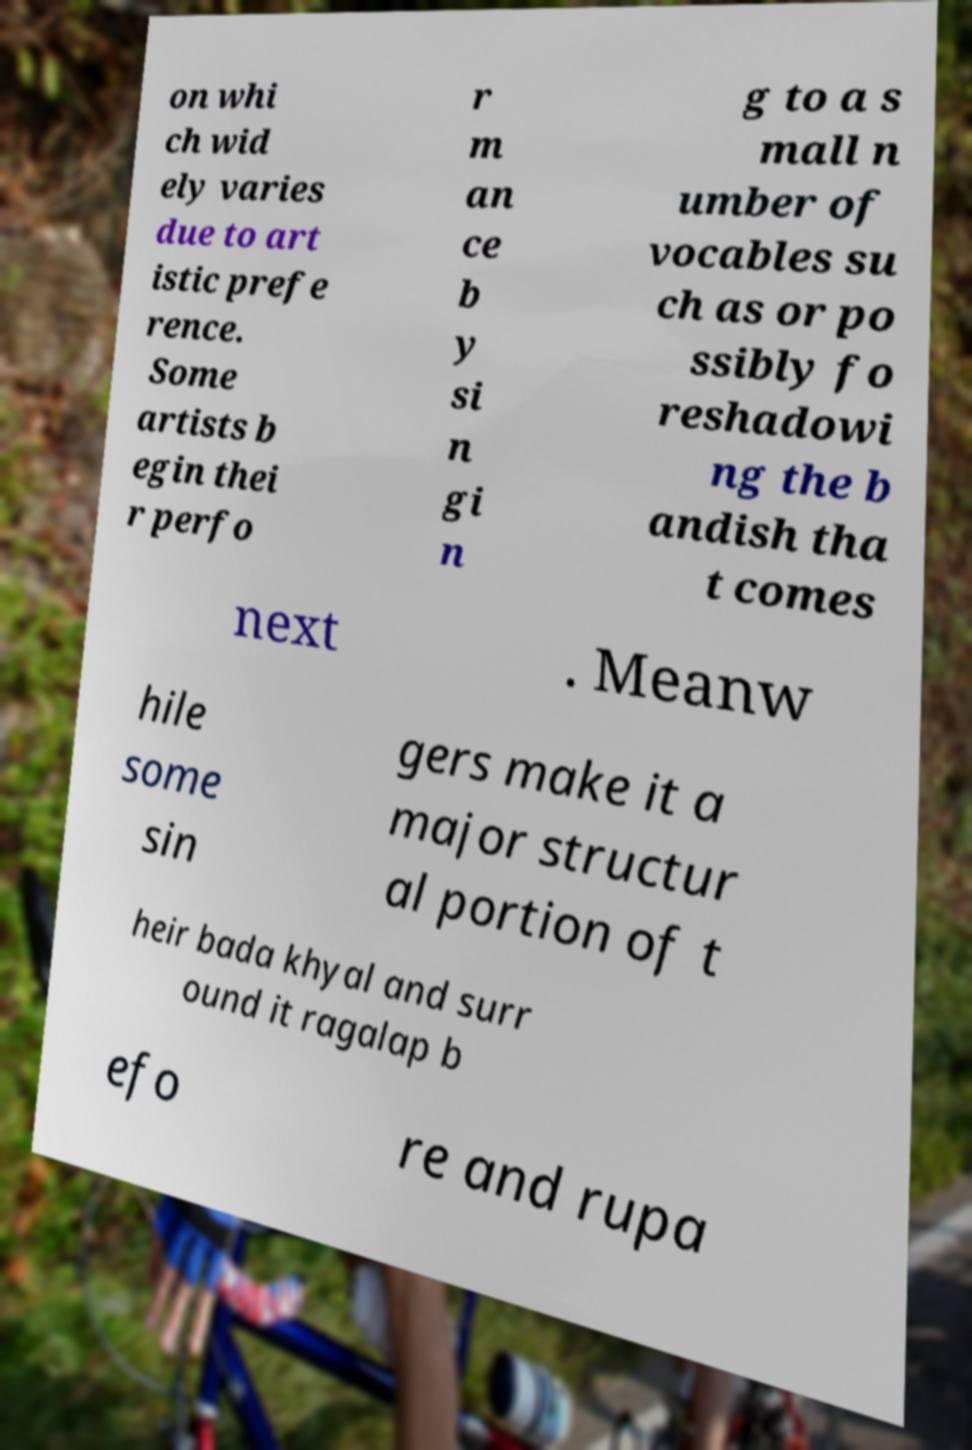Could you extract and type out the text from this image? on whi ch wid ely varies due to art istic prefe rence. Some artists b egin thei r perfo r m an ce b y si n gi n g to a s mall n umber of vocables su ch as or po ssibly fo reshadowi ng the b andish tha t comes next . Meanw hile some sin gers make it a major structur al portion of t heir bada khyal and surr ound it ragalap b efo re and rupa 